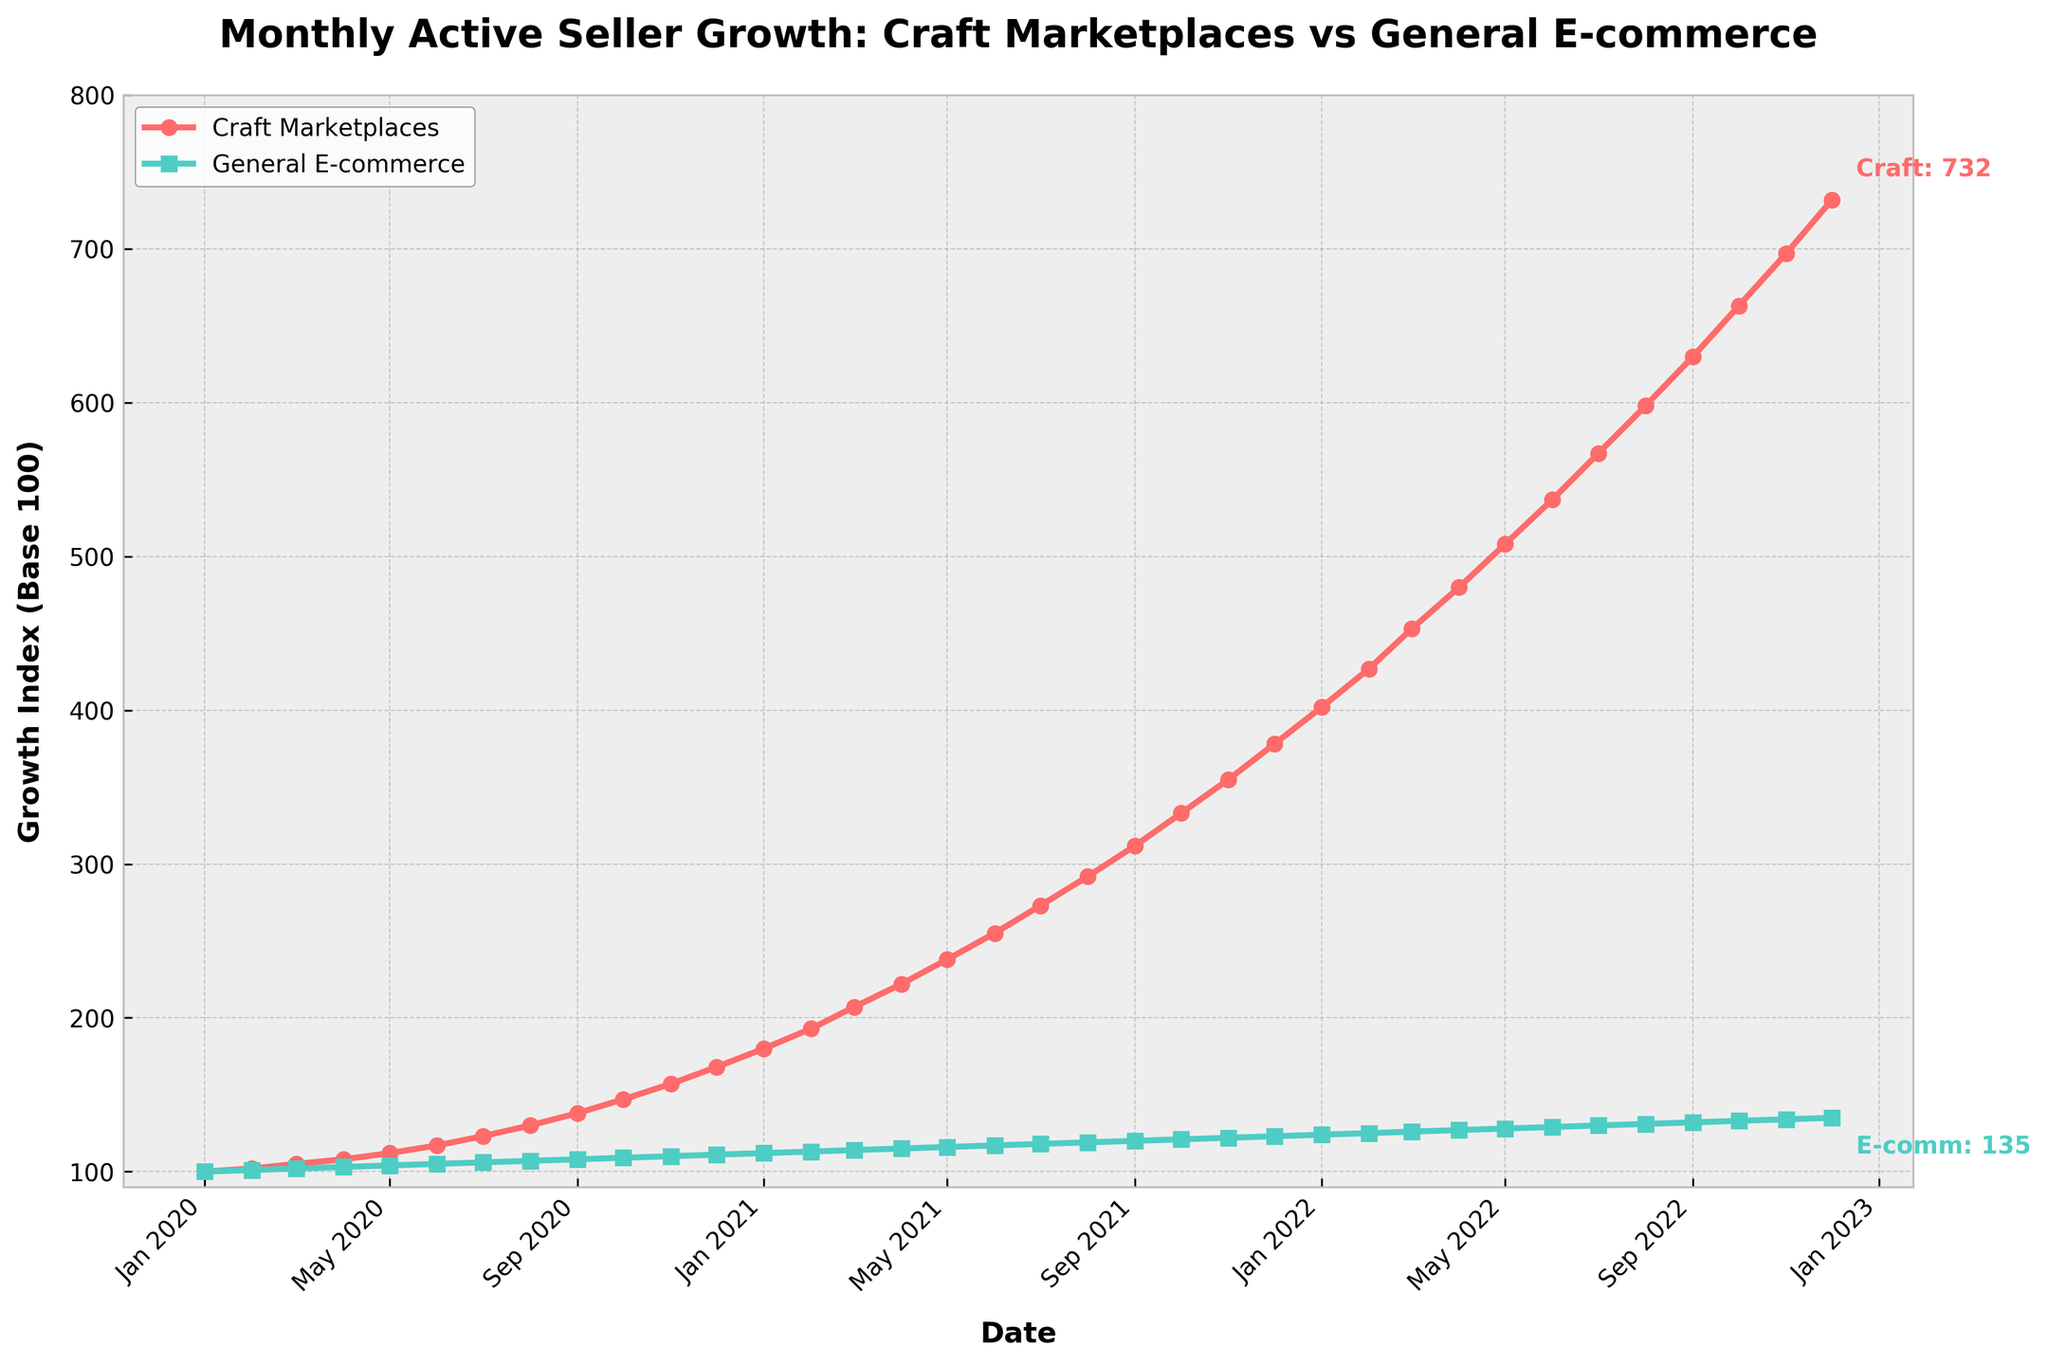What is the growth index for Craft Marketplaces in January 2021? Look for the data point corresponding to January 2021 on the red line representing Craft Marketplaces. The growth index for that month is highlighted with an annotation near the top-left part of the figure.
Answer: 180 How much did the number of active sellers on Craft Marketplaces grow from January 2020 to December 2022? Identify the values for Craft Marketplaces in January 2020 and December 2022. Subtract the value for January 2020 from December 2022 to get the growth. Specifically, 732 - 100.
Answer: 632 Which platform showed greater growth in active sellers by December 2022, Craft Marketplaces or General E-commerce? Compare the final data points for the two lines in December 2022. The red line for Craft Marketplaces ends at a higher point than the green line for General E-commerce.
Answer: Craft Marketplaces By how many points did the Craft Marketplaces' growth index exceed the General E-commerce growth index in December 2022? Find the growth indices for both Craft Marketplaces and General E-commerce in December 2022, then subtract the index for General E-commerce from that for Craft Marketplaces. Specifically, 732 - 135.
Answer: 597 What is the trend of active seller growth for both platforms over the three years? Observe the overall direction of both lines from January 2020 to December 2022. Both lines show a steady upward trend, indicating growth over time.
Answer: Upwards During which month and year did the Craft Marketplaces first exceed a growth index of 200? Identify the point where the red line first crosses the index value of 200. This occurs in March 2021.
Answer: March 2021 Compare the slopes of the lines between April 2020 and October 2020. Which platform had a steeper growth trend? Examine the segments of the lines between April 2020 and October 2020. The red line for Craft Marketplaces shows a steeper increase compared to the green line for General E-commerce.
Answer: Craft Marketplaces What visual elements are used to differentiate the two platforms on the chart? Observe the colors, markers, and line styles used in the chart. The Craft Marketplaces are depicted with a red line and circular markers, while General E-commerce is shown with a green line and square markers.
Answer: Colors, markers How much did the General E-commerce growth index increase between July 2021 and July 2022? Determine the values for General E-commerce in July 2021 and July 2022. Subtract the July 2021 value from the July 2022 value (130 - 118).
Answer: 12 During which period did both platforms maintain a relatively steady and close growth index difference? Observe the line segments where the gap between the two lines remains relatively constant. From January 2020 to around July 2020, the difference remains small and relatively steady.
Answer: January 2020 - July 2020 